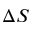<formula> <loc_0><loc_0><loc_500><loc_500>\Delta S</formula> 